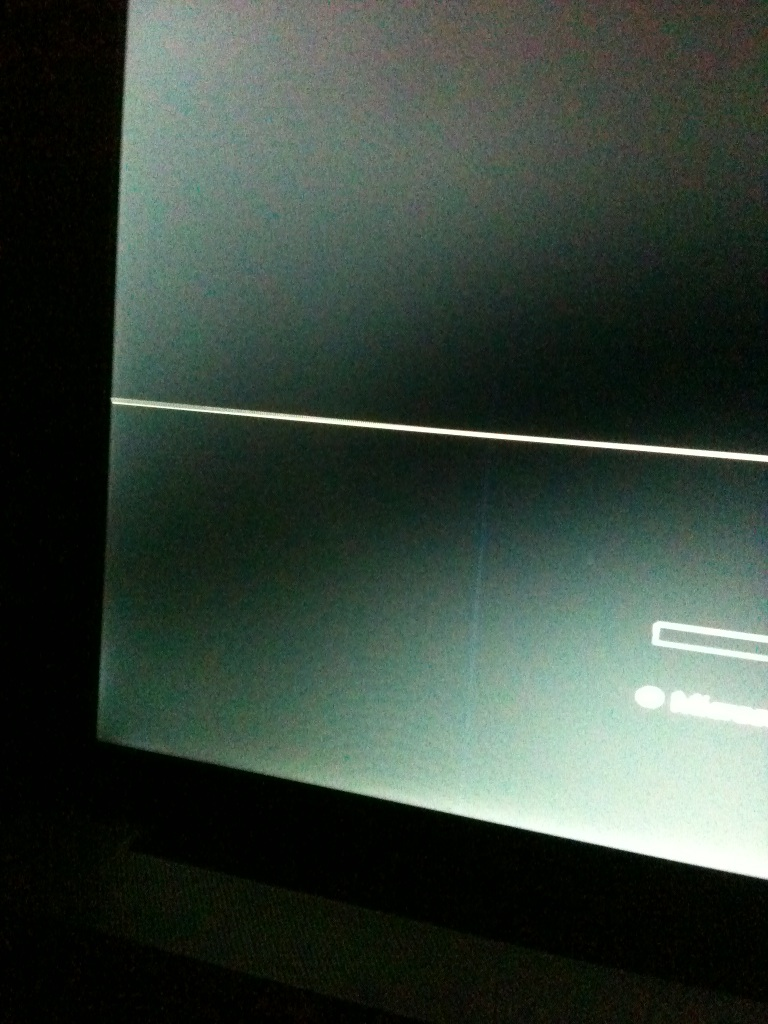Can you describe any visible features on the dark screen? The screen shows a faint, horizontal line across the middle, suggesting a visual or structural division. Additionally, there's a dimly lit rectangular area at the bottom, which might be a dialogue box or some form of user interface element. Is there anything else that can be discerned from this image? Beyond the visible line and box, the rest of the screen is shrouded in darkness, complicating the identification of other elements. The image quality does not permit a clear view of any more detailed content. 